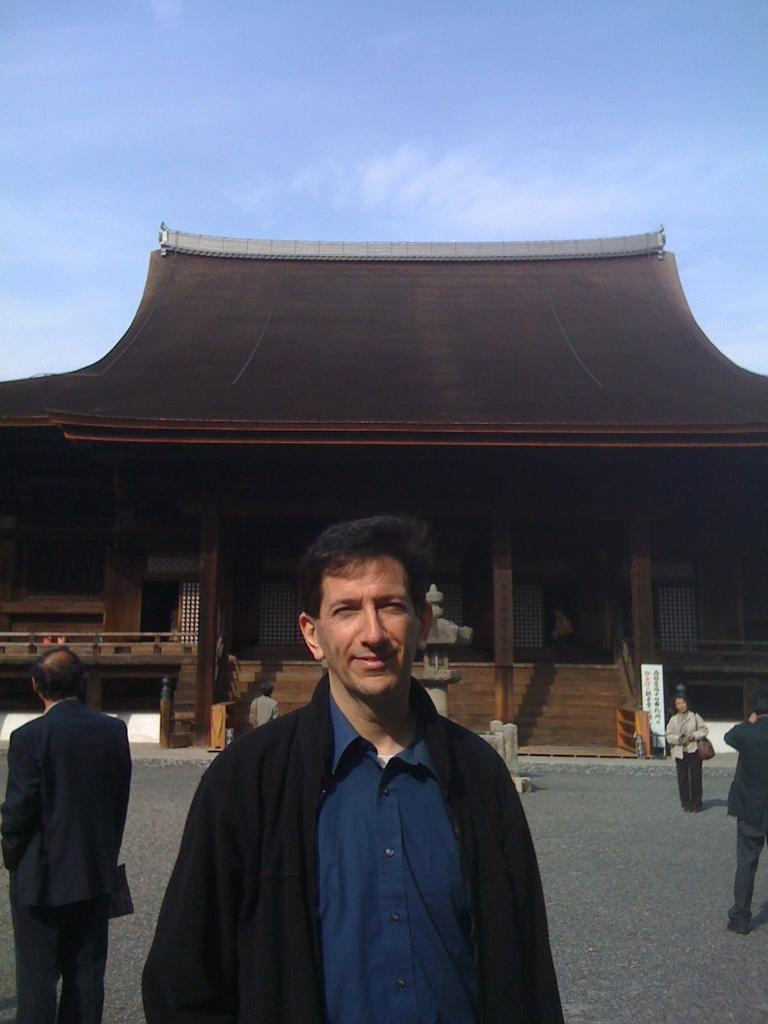What is the main subject of the image? There is a man in the image. Can you describe the man's clothing? The man is wearing a blue shirt and a black coat. Are there any other people in the image? Yes, there are other people in the image. What can be seen in the background of the image? There is a brown building in the background. Can you describe the brown building? The brown building has a fence and pillars. Can you tell me how many times the man has been bitten by a zephyr in the image? There is no mention of a zephyr or any biting in the image, so this question cannot be answered. 